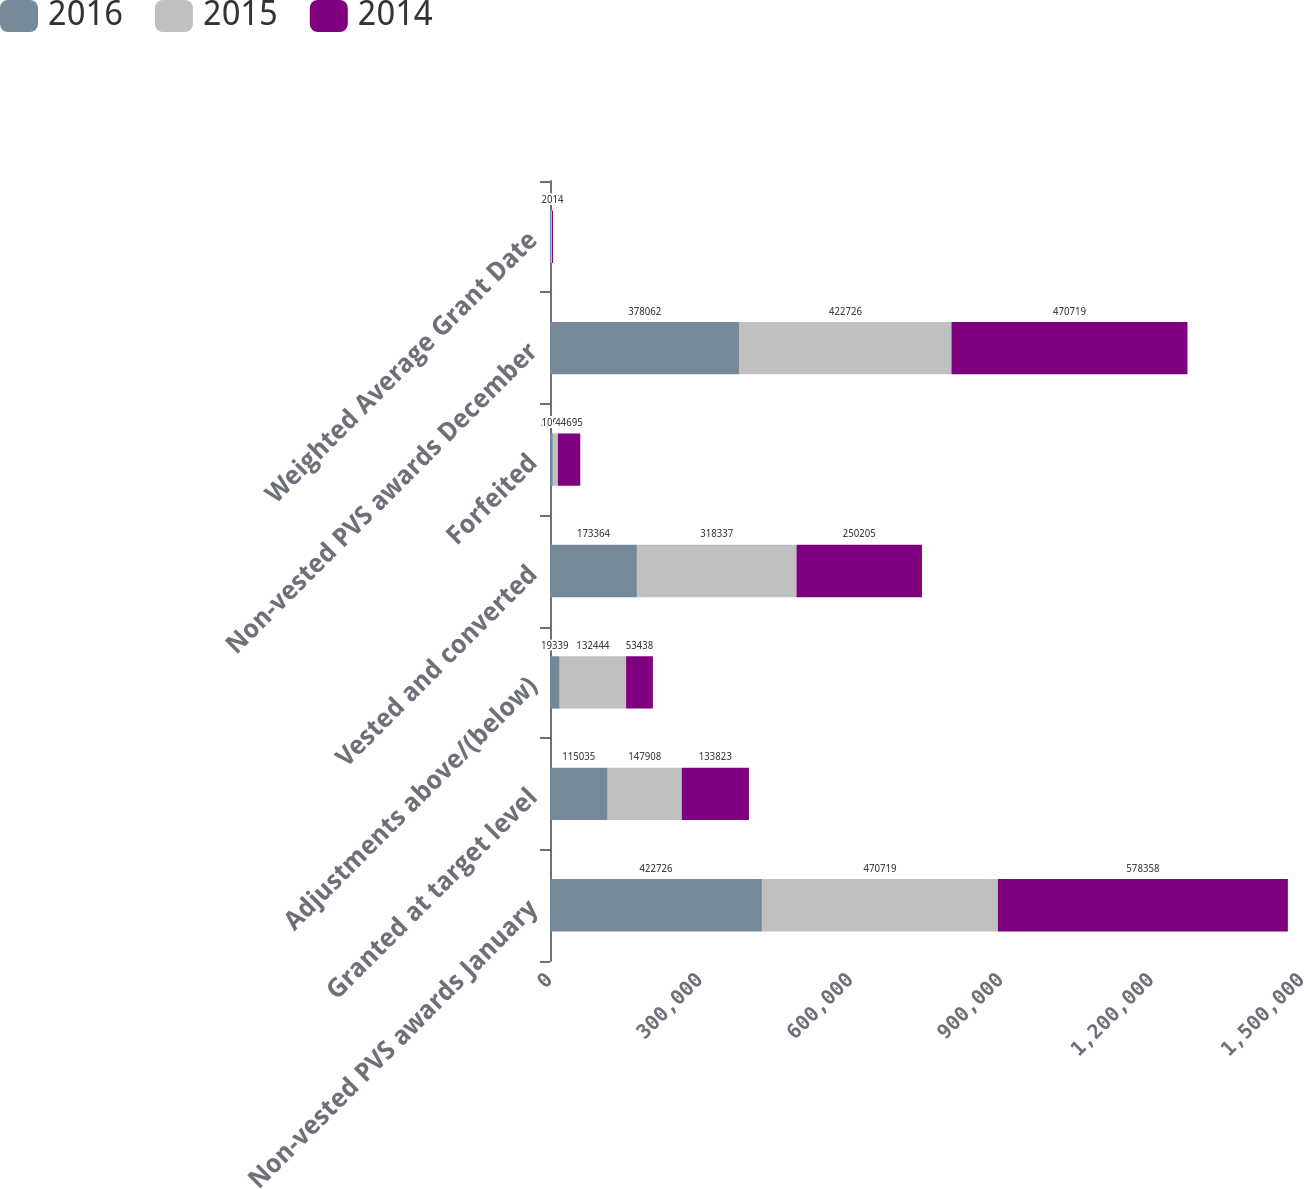Convert chart. <chart><loc_0><loc_0><loc_500><loc_500><stacked_bar_chart><ecel><fcel>Non-vested PVS awards January<fcel>Granted at target level<fcel>Adjustments above/(below)<fcel>Vested and converted<fcel>Forfeited<fcel>Non-vested PVS awards December<fcel>Weighted Average Grant Date<nl><fcel>2016<fcel>422726<fcel>115035<fcel>19339<fcel>173364<fcel>5674<fcel>378062<fcel>2016<nl><fcel>2015<fcel>470719<fcel>147908<fcel>132444<fcel>318337<fcel>10008<fcel>422726<fcel>2015<nl><fcel>2014<fcel>578358<fcel>133823<fcel>53438<fcel>250205<fcel>44695<fcel>470719<fcel>2014<nl></chart> 